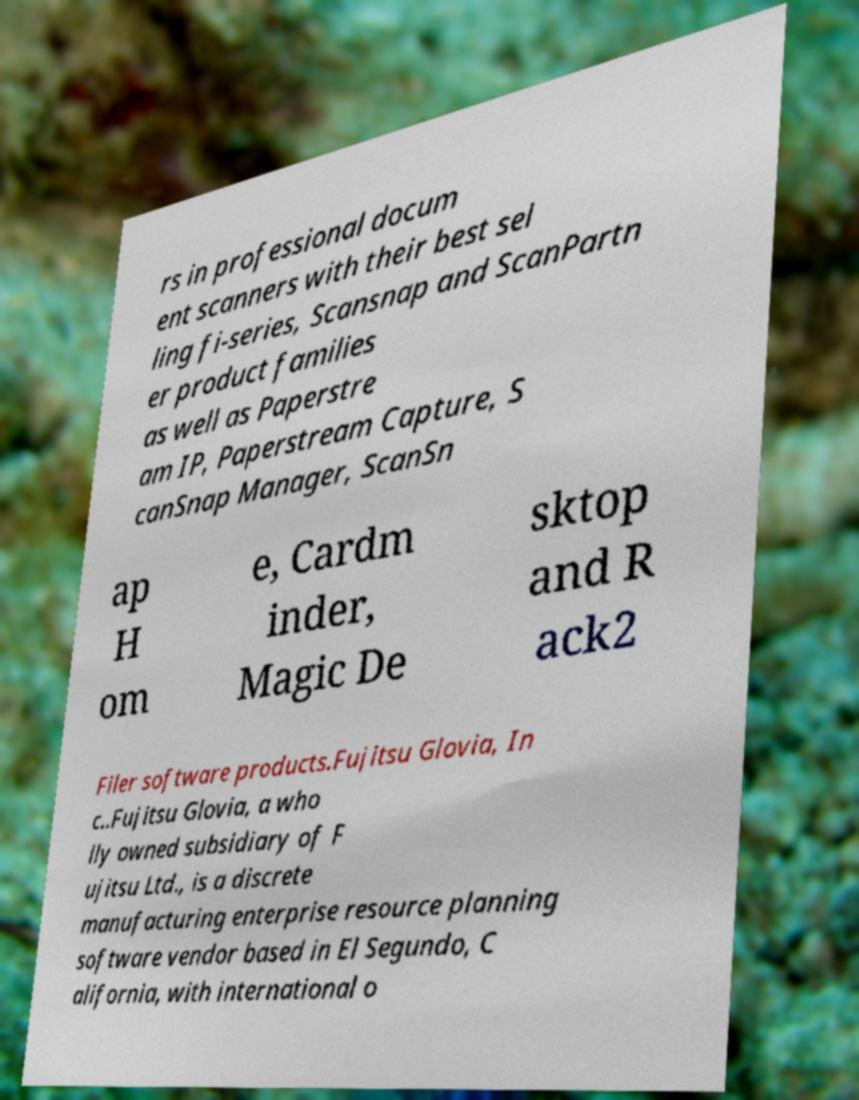There's text embedded in this image that I need extracted. Can you transcribe it verbatim? rs in professional docum ent scanners with their best sel ling fi-series, Scansnap and ScanPartn er product families as well as Paperstre am IP, Paperstream Capture, S canSnap Manager, ScanSn ap H om e, Cardm inder, Magic De sktop and R ack2 Filer software products.Fujitsu Glovia, In c..Fujitsu Glovia, a who lly owned subsidiary of F ujitsu Ltd., is a discrete manufacturing enterprise resource planning software vendor based in El Segundo, C alifornia, with international o 